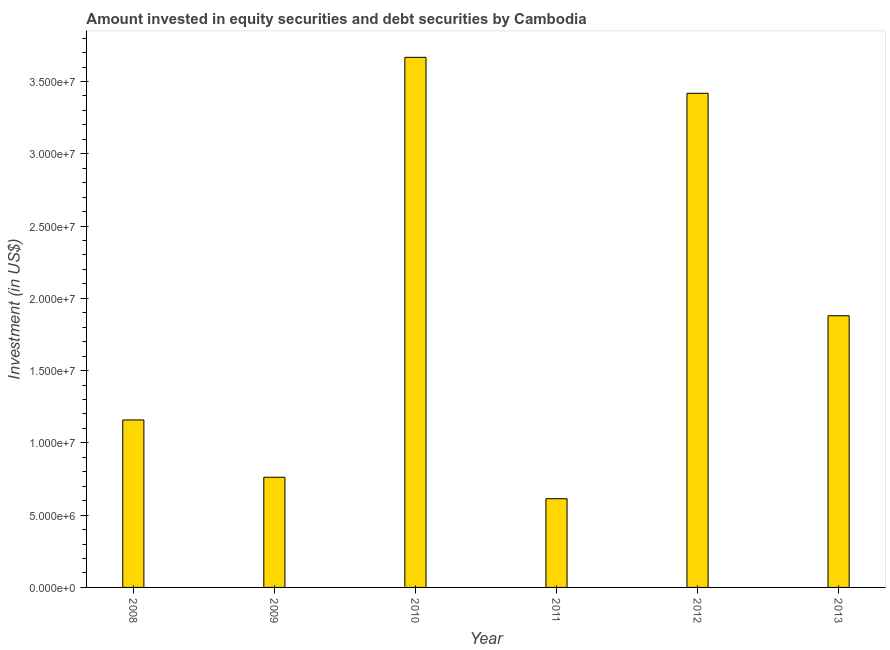Does the graph contain grids?
Your answer should be compact. No. What is the title of the graph?
Make the answer very short. Amount invested in equity securities and debt securities by Cambodia. What is the label or title of the X-axis?
Provide a short and direct response. Year. What is the label or title of the Y-axis?
Provide a succinct answer. Investment (in US$). What is the portfolio investment in 2013?
Your answer should be very brief. 1.88e+07. Across all years, what is the maximum portfolio investment?
Your response must be concise. 3.67e+07. Across all years, what is the minimum portfolio investment?
Your response must be concise. 6.14e+06. In which year was the portfolio investment maximum?
Keep it short and to the point. 2010. In which year was the portfolio investment minimum?
Give a very brief answer. 2011. What is the sum of the portfolio investment?
Make the answer very short. 1.15e+08. What is the difference between the portfolio investment in 2010 and 2012?
Provide a succinct answer. 2.49e+06. What is the average portfolio investment per year?
Offer a very short reply. 1.92e+07. What is the median portfolio investment?
Your response must be concise. 1.52e+07. Do a majority of the years between 2009 and 2013 (inclusive) have portfolio investment greater than 8000000 US$?
Provide a short and direct response. Yes. What is the ratio of the portfolio investment in 2009 to that in 2010?
Keep it short and to the point. 0.21. Is the portfolio investment in 2009 less than that in 2010?
Your response must be concise. Yes. Is the difference between the portfolio investment in 2008 and 2011 greater than the difference between any two years?
Offer a very short reply. No. What is the difference between the highest and the second highest portfolio investment?
Your answer should be compact. 2.49e+06. What is the difference between the highest and the lowest portfolio investment?
Provide a succinct answer. 3.05e+07. What is the difference between two consecutive major ticks on the Y-axis?
Offer a very short reply. 5.00e+06. What is the Investment (in US$) of 2008?
Your response must be concise. 1.16e+07. What is the Investment (in US$) in 2009?
Provide a succinct answer. 7.62e+06. What is the Investment (in US$) of 2010?
Your answer should be very brief. 3.67e+07. What is the Investment (in US$) of 2011?
Provide a succinct answer. 6.14e+06. What is the Investment (in US$) of 2012?
Offer a very short reply. 3.42e+07. What is the Investment (in US$) of 2013?
Keep it short and to the point. 1.88e+07. What is the difference between the Investment (in US$) in 2008 and 2009?
Provide a succinct answer. 3.97e+06. What is the difference between the Investment (in US$) in 2008 and 2010?
Your answer should be compact. -2.51e+07. What is the difference between the Investment (in US$) in 2008 and 2011?
Your response must be concise. 5.45e+06. What is the difference between the Investment (in US$) in 2008 and 2012?
Provide a short and direct response. -2.26e+07. What is the difference between the Investment (in US$) in 2008 and 2013?
Provide a short and direct response. -7.21e+06. What is the difference between the Investment (in US$) in 2009 and 2010?
Offer a terse response. -2.90e+07. What is the difference between the Investment (in US$) in 2009 and 2011?
Ensure brevity in your answer.  1.48e+06. What is the difference between the Investment (in US$) in 2009 and 2012?
Offer a terse response. -2.66e+07. What is the difference between the Investment (in US$) in 2009 and 2013?
Provide a short and direct response. -1.12e+07. What is the difference between the Investment (in US$) in 2010 and 2011?
Your response must be concise. 3.05e+07. What is the difference between the Investment (in US$) in 2010 and 2012?
Ensure brevity in your answer.  2.49e+06. What is the difference between the Investment (in US$) in 2010 and 2013?
Make the answer very short. 1.79e+07. What is the difference between the Investment (in US$) in 2011 and 2012?
Ensure brevity in your answer.  -2.80e+07. What is the difference between the Investment (in US$) in 2011 and 2013?
Offer a very short reply. -1.27e+07. What is the difference between the Investment (in US$) in 2012 and 2013?
Your answer should be very brief. 1.54e+07. What is the ratio of the Investment (in US$) in 2008 to that in 2009?
Make the answer very short. 1.52. What is the ratio of the Investment (in US$) in 2008 to that in 2010?
Your answer should be very brief. 0.32. What is the ratio of the Investment (in US$) in 2008 to that in 2011?
Give a very brief answer. 1.89. What is the ratio of the Investment (in US$) in 2008 to that in 2012?
Provide a short and direct response. 0.34. What is the ratio of the Investment (in US$) in 2008 to that in 2013?
Make the answer very short. 0.62. What is the ratio of the Investment (in US$) in 2009 to that in 2010?
Provide a succinct answer. 0.21. What is the ratio of the Investment (in US$) in 2009 to that in 2011?
Offer a very short reply. 1.24. What is the ratio of the Investment (in US$) in 2009 to that in 2012?
Your answer should be very brief. 0.22. What is the ratio of the Investment (in US$) in 2009 to that in 2013?
Your response must be concise. 0.41. What is the ratio of the Investment (in US$) in 2010 to that in 2011?
Give a very brief answer. 5.97. What is the ratio of the Investment (in US$) in 2010 to that in 2012?
Your response must be concise. 1.07. What is the ratio of the Investment (in US$) in 2010 to that in 2013?
Make the answer very short. 1.95. What is the ratio of the Investment (in US$) in 2011 to that in 2012?
Make the answer very short. 0.18. What is the ratio of the Investment (in US$) in 2011 to that in 2013?
Your answer should be very brief. 0.33. What is the ratio of the Investment (in US$) in 2012 to that in 2013?
Your answer should be compact. 1.82. 